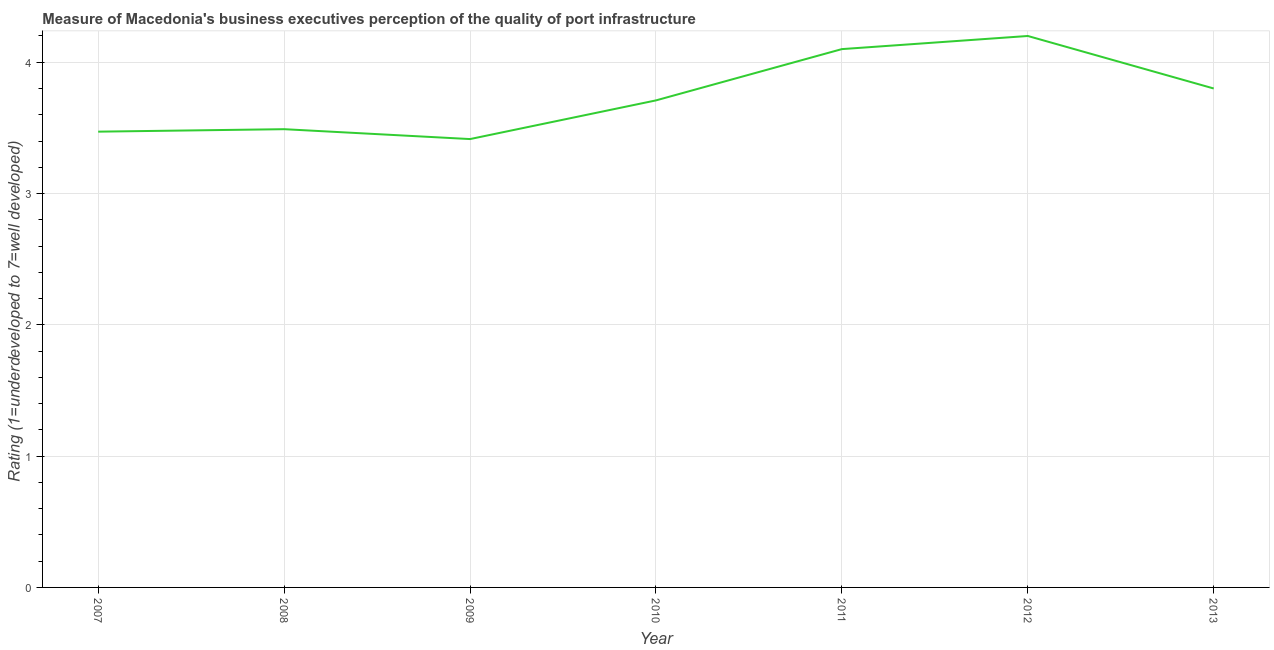What is the rating measuring quality of port infrastructure in 2011?
Keep it short and to the point. 4.1. Across all years, what is the maximum rating measuring quality of port infrastructure?
Offer a terse response. 4.2. Across all years, what is the minimum rating measuring quality of port infrastructure?
Offer a very short reply. 3.41. In which year was the rating measuring quality of port infrastructure minimum?
Provide a short and direct response. 2009. What is the sum of the rating measuring quality of port infrastructure?
Your response must be concise. 26.19. What is the difference between the rating measuring quality of port infrastructure in 2009 and 2011?
Provide a short and direct response. -0.69. What is the average rating measuring quality of port infrastructure per year?
Your answer should be very brief. 3.74. What is the median rating measuring quality of port infrastructure?
Offer a terse response. 3.71. In how many years, is the rating measuring quality of port infrastructure greater than 1.4 ?
Keep it short and to the point. 7. Do a majority of the years between 2010 and 2012 (inclusive) have rating measuring quality of port infrastructure greater than 0.8 ?
Provide a succinct answer. Yes. What is the ratio of the rating measuring quality of port infrastructure in 2008 to that in 2012?
Your answer should be very brief. 0.83. Is the rating measuring quality of port infrastructure in 2009 less than that in 2010?
Keep it short and to the point. Yes. What is the difference between the highest and the second highest rating measuring quality of port infrastructure?
Your answer should be very brief. 0.1. Is the sum of the rating measuring quality of port infrastructure in 2007 and 2013 greater than the maximum rating measuring quality of port infrastructure across all years?
Provide a short and direct response. Yes. What is the difference between the highest and the lowest rating measuring quality of port infrastructure?
Offer a terse response. 0.79. How many years are there in the graph?
Provide a succinct answer. 7. What is the difference between two consecutive major ticks on the Y-axis?
Your answer should be very brief. 1. Are the values on the major ticks of Y-axis written in scientific E-notation?
Your answer should be very brief. No. Does the graph contain any zero values?
Give a very brief answer. No. Does the graph contain grids?
Offer a very short reply. Yes. What is the title of the graph?
Ensure brevity in your answer.  Measure of Macedonia's business executives perception of the quality of port infrastructure. What is the label or title of the X-axis?
Keep it short and to the point. Year. What is the label or title of the Y-axis?
Keep it short and to the point. Rating (1=underdeveloped to 7=well developed) . What is the Rating (1=underdeveloped to 7=well developed)  of 2007?
Keep it short and to the point. 3.47. What is the Rating (1=underdeveloped to 7=well developed)  in 2008?
Your response must be concise. 3.49. What is the Rating (1=underdeveloped to 7=well developed)  in 2009?
Offer a terse response. 3.41. What is the Rating (1=underdeveloped to 7=well developed)  of 2010?
Offer a very short reply. 3.71. What is the Rating (1=underdeveloped to 7=well developed)  in 2012?
Ensure brevity in your answer.  4.2. What is the difference between the Rating (1=underdeveloped to 7=well developed)  in 2007 and 2008?
Offer a very short reply. -0.02. What is the difference between the Rating (1=underdeveloped to 7=well developed)  in 2007 and 2009?
Your answer should be very brief. 0.06. What is the difference between the Rating (1=underdeveloped to 7=well developed)  in 2007 and 2010?
Offer a very short reply. -0.24. What is the difference between the Rating (1=underdeveloped to 7=well developed)  in 2007 and 2011?
Offer a terse response. -0.63. What is the difference between the Rating (1=underdeveloped to 7=well developed)  in 2007 and 2012?
Give a very brief answer. -0.73. What is the difference between the Rating (1=underdeveloped to 7=well developed)  in 2007 and 2013?
Your response must be concise. -0.33. What is the difference between the Rating (1=underdeveloped to 7=well developed)  in 2008 and 2009?
Provide a short and direct response. 0.08. What is the difference between the Rating (1=underdeveloped to 7=well developed)  in 2008 and 2010?
Make the answer very short. -0.22. What is the difference between the Rating (1=underdeveloped to 7=well developed)  in 2008 and 2011?
Your response must be concise. -0.61. What is the difference between the Rating (1=underdeveloped to 7=well developed)  in 2008 and 2012?
Provide a short and direct response. -0.71. What is the difference between the Rating (1=underdeveloped to 7=well developed)  in 2008 and 2013?
Your answer should be very brief. -0.31. What is the difference between the Rating (1=underdeveloped to 7=well developed)  in 2009 and 2010?
Offer a very short reply. -0.29. What is the difference between the Rating (1=underdeveloped to 7=well developed)  in 2009 and 2011?
Offer a terse response. -0.69. What is the difference between the Rating (1=underdeveloped to 7=well developed)  in 2009 and 2012?
Your answer should be compact. -0.79. What is the difference between the Rating (1=underdeveloped to 7=well developed)  in 2009 and 2013?
Your answer should be very brief. -0.39. What is the difference between the Rating (1=underdeveloped to 7=well developed)  in 2010 and 2011?
Provide a succinct answer. -0.39. What is the difference between the Rating (1=underdeveloped to 7=well developed)  in 2010 and 2012?
Provide a succinct answer. -0.49. What is the difference between the Rating (1=underdeveloped to 7=well developed)  in 2010 and 2013?
Your answer should be very brief. -0.09. What is the difference between the Rating (1=underdeveloped to 7=well developed)  in 2011 and 2012?
Keep it short and to the point. -0.1. What is the difference between the Rating (1=underdeveloped to 7=well developed)  in 2011 and 2013?
Ensure brevity in your answer.  0.3. What is the difference between the Rating (1=underdeveloped to 7=well developed)  in 2012 and 2013?
Offer a very short reply. 0.4. What is the ratio of the Rating (1=underdeveloped to 7=well developed)  in 2007 to that in 2008?
Make the answer very short. 0.99. What is the ratio of the Rating (1=underdeveloped to 7=well developed)  in 2007 to that in 2010?
Provide a short and direct response. 0.94. What is the ratio of the Rating (1=underdeveloped to 7=well developed)  in 2007 to that in 2011?
Give a very brief answer. 0.85. What is the ratio of the Rating (1=underdeveloped to 7=well developed)  in 2007 to that in 2012?
Your response must be concise. 0.83. What is the ratio of the Rating (1=underdeveloped to 7=well developed)  in 2008 to that in 2010?
Offer a terse response. 0.94. What is the ratio of the Rating (1=underdeveloped to 7=well developed)  in 2008 to that in 2011?
Your response must be concise. 0.85. What is the ratio of the Rating (1=underdeveloped to 7=well developed)  in 2008 to that in 2012?
Provide a short and direct response. 0.83. What is the ratio of the Rating (1=underdeveloped to 7=well developed)  in 2008 to that in 2013?
Your answer should be compact. 0.92. What is the ratio of the Rating (1=underdeveloped to 7=well developed)  in 2009 to that in 2010?
Your answer should be very brief. 0.92. What is the ratio of the Rating (1=underdeveloped to 7=well developed)  in 2009 to that in 2011?
Your answer should be compact. 0.83. What is the ratio of the Rating (1=underdeveloped to 7=well developed)  in 2009 to that in 2012?
Ensure brevity in your answer.  0.81. What is the ratio of the Rating (1=underdeveloped to 7=well developed)  in 2009 to that in 2013?
Make the answer very short. 0.9. What is the ratio of the Rating (1=underdeveloped to 7=well developed)  in 2010 to that in 2011?
Your answer should be compact. 0.91. What is the ratio of the Rating (1=underdeveloped to 7=well developed)  in 2010 to that in 2012?
Provide a short and direct response. 0.88. What is the ratio of the Rating (1=underdeveloped to 7=well developed)  in 2010 to that in 2013?
Offer a very short reply. 0.98. What is the ratio of the Rating (1=underdeveloped to 7=well developed)  in 2011 to that in 2013?
Keep it short and to the point. 1.08. What is the ratio of the Rating (1=underdeveloped to 7=well developed)  in 2012 to that in 2013?
Your response must be concise. 1.1. 